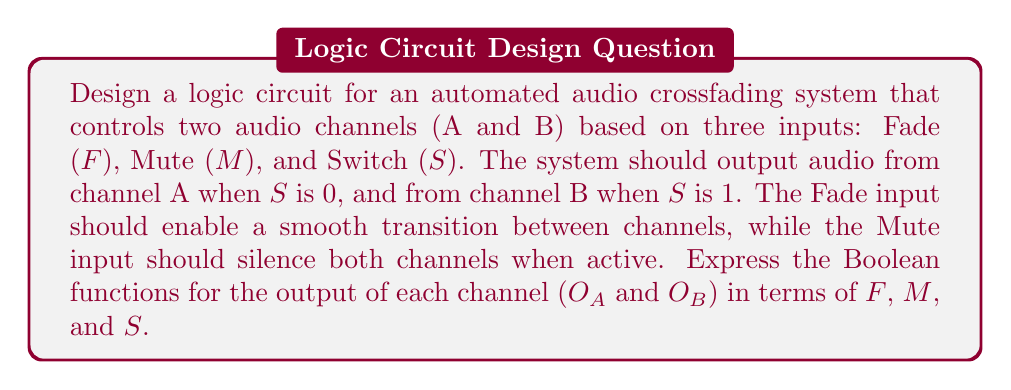Provide a solution to this math problem. Let's approach this step-by-step:

1) First, we need to define the truth table for our system:

   F | M | S | O_A | O_B
   --|---|---|-----|-----
   0 | 0 | 0 |  1  |  0
   0 | 0 | 1 |  0  |  1
   0 | 1 | X |  0  |  0
   1 | 0 | X |  1  |  1
   1 | 1 | X |  0  |  0

   Where X represents "don't care" conditions.

2) From this truth table, we can derive the Boolean functions:

   For O_A:
   $O_A = F \cdot \overline{M} + \overline{F} \cdot \overline{M} \cdot \overline{S}$

   For O_B:
   $O_B = F \cdot \overline{M} + \overline{F} \cdot \overline{M} \cdot S$

3) These functions can be simplified:

   $O_A = \overline{M} \cdot (F + \overline{F} \cdot \overline{S})$
   $O_B = \overline{M} \cdot (F + \overline{F} \cdot S)$

4) The logic circuit for this system would consist of:
   - NOT gates for $\overline{M}$ and $\overline{S}$
   - AND gates to combine terms
   - OR gates to sum the terms

5) The final step would be to implement this circuit using appropriate audio mixing hardware that can accept these logic signals as control inputs.
Answer: $O_A = \overline{M} \cdot (F + \overline{F} \cdot \overline{S})$, $O_B = \overline{M} \cdot (F + \overline{F} \cdot S)$ 